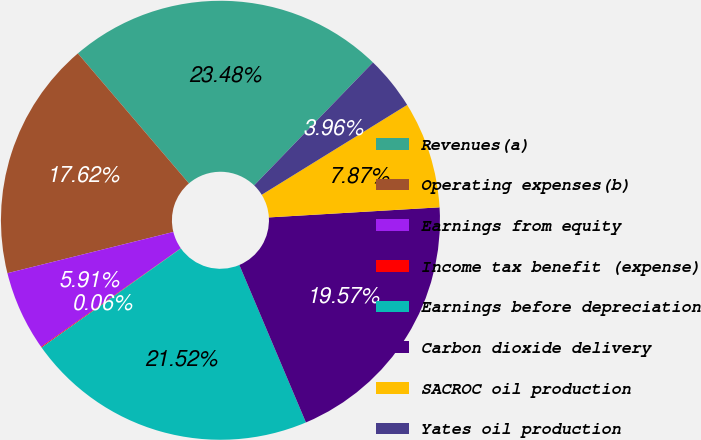<chart> <loc_0><loc_0><loc_500><loc_500><pie_chart><fcel>Revenues(a)<fcel>Operating expenses(b)<fcel>Earnings from equity<fcel>Income tax benefit (expense)<fcel>Earnings before depreciation<fcel>Carbon dioxide delivery<fcel>SACROC oil production<fcel>Yates oil production<nl><fcel>23.48%<fcel>17.62%<fcel>5.91%<fcel>0.06%<fcel>21.52%<fcel>19.57%<fcel>7.87%<fcel>3.96%<nl></chart> 